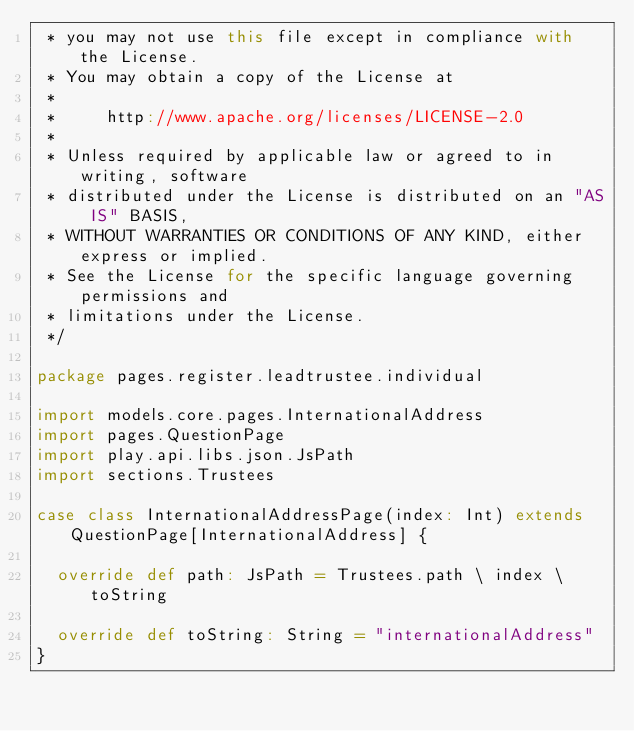Convert code to text. <code><loc_0><loc_0><loc_500><loc_500><_Scala_> * you may not use this file except in compliance with the License.
 * You may obtain a copy of the License at
 *
 *     http://www.apache.org/licenses/LICENSE-2.0
 *
 * Unless required by applicable law or agreed to in writing, software
 * distributed under the License is distributed on an "AS IS" BASIS,
 * WITHOUT WARRANTIES OR CONDITIONS OF ANY KIND, either express or implied.
 * See the License for the specific language governing permissions and
 * limitations under the License.
 */

package pages.register.leadtrustee.individual

import models.core.pages.InternationalAddress
import pages.QuestionPage
import play.api.libs.json.JsPath
import sections.Trustees

case class InternationalAddressPage(index: Int) extends QuestionPage[InternationalAddress] {

  override def path: JsPath = Trustees.path \ index \ toString

  override def toString: String = "internationalAddress"
}
</code> 